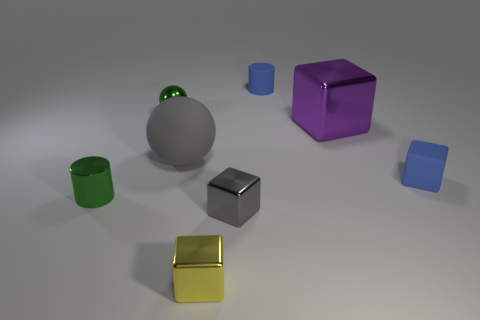Is there anything else that is the same color as the tiny metallic cylinder?
Offer a very short reply. Yes. What shape is the shiny object that is on the right side of the tiny cylinder behind the gray object behind the tiny gray block?
Keep it short and to the point. Cube. Do the green object that is behind the tiny green shiny cylinder and the green thing that is to the left of the green ball have the same size?
Your answer should be compact. Yes. How many cylinders are made of the same material as the purple object?
Provide a short and direct response. 1. What number of small cylinders are in front of the green thing that is behind the cylinder that is in front of the green metal sphere?
Your answer should be very brief. 1. Does the large rubber object have the same shape as the gray metallic object?
Keep it short and to the point. No. Is there another yellow rubber object of the same shape as the yellow object?
Your response must be concise. No. There is a yellow shiny object that is the same size as the gray block; what shape is it?
Keep it short and to the point. Cube. The tiny cylinder that is in front of the small green thing to the right of the small cylinder in front of the tiny blue cylinder is made of what material?
Provide a short and direct response. Metal. Is the blue cylinder the same size as the gray cube?
Provide a short and direct response. Yes. 